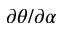<formula> <loc_0><loc_0><loc_500><loc_500>\partial \theta / \partial \alpha</formula> 